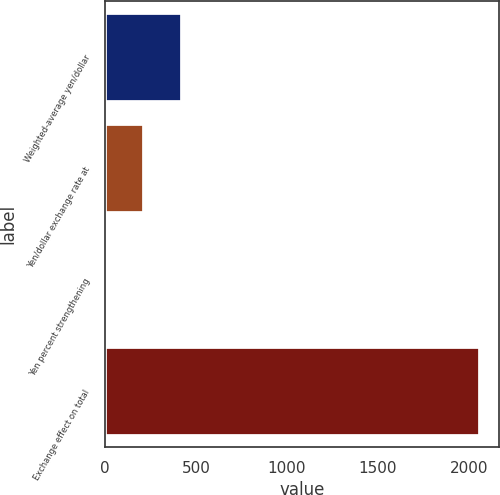Convert chart to OTSL. <chart><loc_0><loc_0><loc_500><loc_500><bar_chart><fcel>Weighted-average yen/dollar<fcel>Yen/dollar exchange rate at<fcel>Yen percent strengthening<fcel>Exchange effect on total<nl><fcel>423.84<fcel>214.07<fcel>4.3<fcel>2063<nl></chart> 